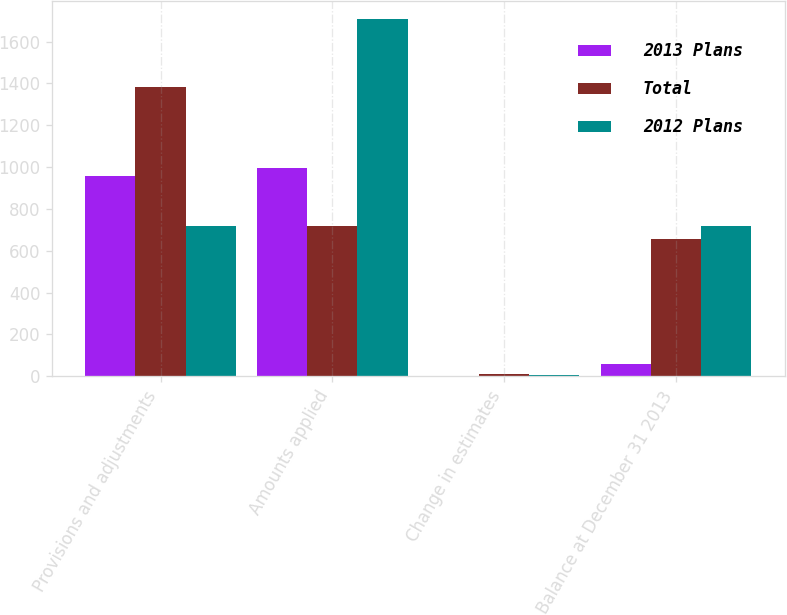<chart> <loc_0><loc_0><loc_500><loc_500><stacked_bar_chart><ecel><fcel>Provisions and adjustments<fcel>Amounts applied<fcel>Change in estimates<fcel>Balance at December 31 2013<nl><fcel>2013 Plans<fcel>957<fcel>994<fcel>1<fcel>58<nl><fcel>Total<fcel>1383<fcel>716<fcel>9<fcel>658<nl><fcel>2012 Plans<fcel>716<fcel>1710<fcel>8<fcel>716<nl></chart> 